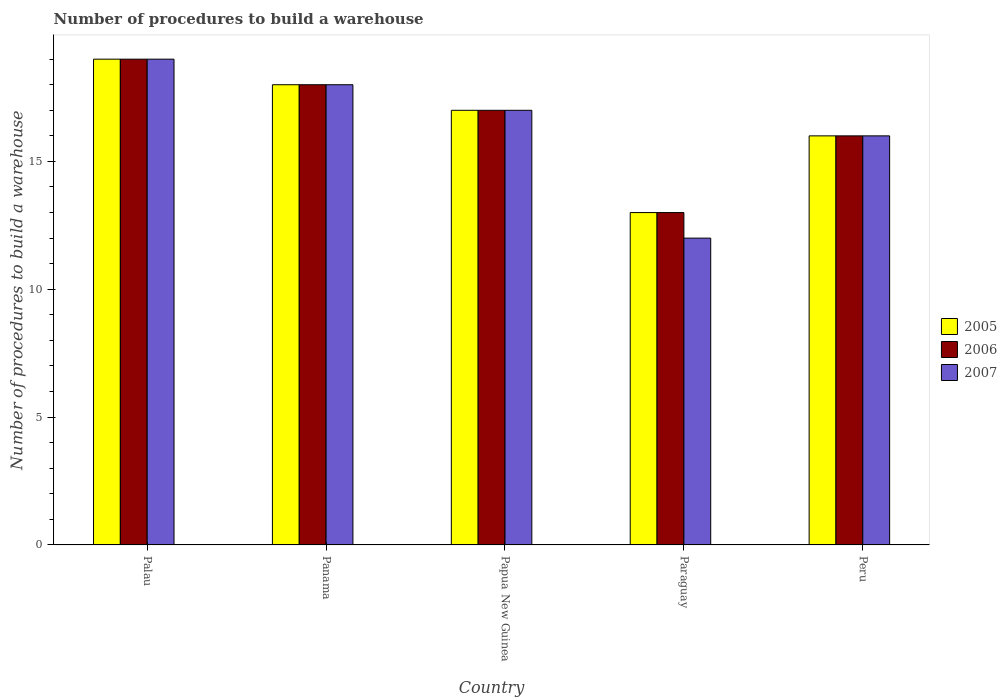How many different coloured bars are there?
Provide a short and direct response. 3. How many bars are there on the 2nd tick from the left?
Offer a very short reply. 3. What is the label of the 1st group of bars from the left?
Provide a succinct answer. Palau. What is the number of procedures to build a warehouse in in 2005 in Peru?
Your response must be concise. 16. Across all countries, what is the maximum number of procedures to build a warehouse in in 2007?
Keep it short and to the point. 19. In which country was the number of procedures to build a warehouse in in 2006 maximum?
Make the answer very short. Palau. In which country was the number of procedures to build a warehouse in in 2005 minimum?
Your answer should be very brief. Paraguay. What is the total number of procedures to build a warehouse in in 2007 in the graph?
Provide a short and direct response. 82. What is the difference between the number of procedures to build a warehouse in in 2007 in Peru and the number of procedures to build a warehouse in in 2005 in Panama?
Offer a terse response. -2. What is the difference between the number of procedures to build a warehouse in of/in 2007 and number of procedures to build a warehouse in of/in 2005 in Papua New Guinea?
Ensure brevity in your answer.  0. Is the number of procedures to build a warehouse in in 2005 in Palau less than that in Paraguay?
Offer a very short reply. No. Is it the case that in every country, the sum of the number of procedures to build a warehouse in in 2005 and number of procedures to build a warehouse in in 2007 is greater than the number of procedures to build a warehouse in in 2006?
Keep it short and to the point. Yes. How many bars are there?
Give a very brief answer. 15. Are all the bars in the graph horizontal?
Make the answer very short. No. How many countries are there in the graph?
Keep it short and to the point. 5. Does the graph contain any zero values?
Your answer should be very brief. No. Does the graph contain grids?
Provide a short and direct response. No. Where does the legend appear in the graph?
Ensure brevity in your answer.  Center right. How are the legend labels stacked?
Your answer should be compact. Vertical. What is the title of the graph?
Your response must be concise. Number of procedures to build a warehouse. What is the label or title of the X-axis?
Your answer should be compact. Country. What is the label or title of the Y-axis?
Make the answer very short. Number of procedures to build a warehouse. What is the Number of procedures to build a warehouse of 2005 in Palau?
Offer a very short reply. 19. What is the Number of procedures to build a warehouse of 2005 in Paraguay?
Provide a short and direct response. 13. What is the Number of procedures to build a warehouse in 2006 in Paraguay?
Your answer should be compact. 13. What is the Number of procedures to build a warehouse of 2007 in Paraguay?
Offer a very short reply. 12. What is the Number of procedures to build a warehouse of 2005 in Peru?
Offer a very short reply. 16. What is the Number of procedures to build a warehouse in 2007 in Peru?
Provide a succinct answer. 16. Across all countries, what is the maximum Number of procedures to build a warehouse of 2005?
Provide a short and direct response. 19. Across all countries, what is the minimum Number of procedures to build a warehouse in 2005?
Provide a short and direct response. 13. What is the total Number of procedures to build a warehouse in 2005 in the graph?
Your answer should be compact. 83. What is the total Number of procedures to build a warehouse in 2006 in the graph?
Offer a very short reply. 83. What is the total Number of procedures to build a warehouse in 2007 in the graph?
Provide a short and direct response. 82. What is the difference between the Number of procedures to build a warehouse of 2006 in Palau and that in Panama?
Your answer should be very brief. 1. What is the difference between the Number of procedures to build a warehouse of 2007 in Palau and that in Panama?
Offer a very short reply. 1. What is the difference between the Number of procedures to build a warehouse in 2005 in Palau and that in Papua New Guinea?
Provide a succinct answer. 2. What is the difference between the Number of procedures to build a warehouse in 2006 in Palau and that in Papua New Guinea?
Your answer should be compact. 2. What is the difference between the Number of procedures to build a warehouse of 2006 in Palau and that in Paraguay?
Your answer should be compact. 6. What is the difference between the Number of procedures to build a warehouse in 2007 in Palau and that in Paraguay?
Make the answer very short. 7. What is the difference between the Number of procedures to build a warehouse of 2006 in Palau and that in Peru?
Ensure brevity in your answer.  3. What is the difference between the Number of procedures to build a warehouse in 2006 in Panama and that in Papua New Guinea?
Offer a very short reply. 1. What is the difference between the Number of procedures to build a warehouse in 2005 in Panama and that in Paraguay?
Ensure brevity in your answer.  5. What is the difference between the Number of procedures to build a warehouse in 2007 in Panama and that in Paraguay?
Offer a terse response. 6. What is the difference between the Number of procedures to build a warehouse of 2005 in Panama and that in Peru?
Give a very brief answer. 2. What is the difference between the Number of procedures to build a warehouse in 2005 in Papua New Guinea and that in Paraguay?
Offer a terse response. 4. What is the difference between the Number of procedures to build a warehouse of 2006 in Papua New Guinea and that in Paraguay?
Ensure brevity in your answer.  4. What is the difference between the Number of procedures to build a warehouse in 2005 in Papua New Guinea and that in Peru?
Your response must be concise. 1. What is the difference between the Number of procedures to build a warehouse in 2006 in Papua New Guinea and that in Peru?
Your response must be concise. 1. What is the difference between the Number of procedures to build a warehouse of 2007 in Papua New Guinea and that in Peru?
Give a very brief answer. 1. What is the difference between the Number of procedures to build a warehouse in 2006 in Palau and the Number of procedures to build a warehouse in 2007 in Panama?
Provide a succinct answer. 1. What is the difference between the Number of procedures to build a warehouse in 2005 in Palau and the Number of procedures to build a warehouse in 2006 in Papua New Guinea?
Your answer should be very brief. 2. What is the difference between the Number of procedures to build a warehouse in 2006 in Palau and the Number of procedures to build a warehouse in 2007 in Papua New Guinea?
Offer a terse response. 2. What is the difference between the Number of procedures to build a warehouse of 2005 in Palau and the Number of procedures to build a warehouse of 2006 in Paraguay?
Your response must be concise. 6. What is the difference between the Number of procedures to build a warehouse in 2005 in Palau and the Number of procedures to build a warehouse in 2007 in Paraguay?
Ensure brevity in your answer.  7. What is the difference between the Number of procedures to build a warehouse of 2006 in Palau and the Number of procedures to build a warehouse of 2007 in Paraguay?
Give a very brief answer. 7. What is the difference between the Number of procedures to build a warehouse in 2005 in Palau and the Number of procedures to build a warehouse in 2006 in Peru?
Provide a short and direct response. 3. What is the difference between the Number of procedures to build a warehouse of 2005 in Palau and the Number of procedures to build a warehouse of 2007 in Peru?
Your answer should be compact. 3. What is the difference between the Number of procedures to build a warehouse in 2006 in Palau and the Number of procedures to build a warehouse in 2007 in Peru?
Provide a short and direct response. 3. What is the difference between the Number of procedures to build a warehouse of 2005 in Panama and the Number of procedures to build a warehouse of 2006 in Papua New Guinea?
Offer a very short reply. 1. What is the difference between the Number of procedures to build a warehouse of 2005 in Panama and the Number of procedures to build a warehouse of 2007 in Papua New Guinea?
Give a very brief answer. 1. What is the difference between the Number of procedures to build a warehouse in 2005 in Panama and the Number of procedures to build a warehouse in 2006 in Paraguay?
Ensure brevity in your answer.  5. What is the difference between the Number of procedures to build a warehouse in 2005 in Papua New Guinea and the Number of procedures to build a warehouse in 2006 in Paraguay?
Offer a terse response. 4. What is the difference between the Number of procedures to build a warehouse in 2006 in Papua New Guinea and the Number of procedures to build a warehouse in 2007 in Paraguay?
Make the answer very short. 5. What is the difference between the Number of procedures to build a warehouse of 2005 in Papua New Guinea and the Number of procedures to build a warehouse of 2007 in Peru?
Make the answer very short. 1. What is the difference between the Number of procedures to build a warehouse of 2006 in Papua New Guinea and the Number of procedures to build a warehouse of 2007 in Peru?
Your answer should be compact. 1. What is the difference between the Number of procedures to build a warehouse of 2005 in Paraguay and the Number of procedures to build a warehouse of 2006 in Peru?
Offer a terse response. -3. What is the difference between the Number of procedures to build a warehouse of 2006 in Paraguay and the Number of procedures to build a warehouse of 2007 in Peru?
Give a very brief answer. -3. What is the average Number of procedures to build a warehouse in 2006 per country?
Offer a terse response. 16.6. What is the average Number of procedures to build a warehouse of 2007 per country?
Provide a succinct answer. 16.4. What is the difference between the Number of procedures to build a warehouse in 2005 and Number of procedures to build a warehouse in 2007 in Palau?
Provide a succinct answer. 0. What is the difference between the Number of procedures to build a warehouse in 2006 and Number of procedures to build a warehouse in 2007 in Palau?
Your answer should be compact. 0. What is the difference between the Number of procedures to build a warehouse of 2005 and Number of procedures to build a warehouse of 2006 in Panama?
Offer a terse response. 0. What is the difference between the Number of procedures to build a warehouse in 2005 and Number of procedures to build a warehouse in 2007 in Panama?
Give a very brief answer. 0. What is the difference between the Number of procedures to build a warehouse of 2006 and Number of procedures to build a warehouse of 2007 in Panama?
Provide a short and direct response. 0. What is the difference between the Number of procedures to build a warehouse of 2005 and Number of procedures to build a warehouse of 2006 in Papua New Guinea?
Provide a short and direct response. 0. What is the difference between the Number of procedures to build a warehouse in 2006 and Number of procedures to build a warehouse in 2007 in Papua New Guinea?
Your response must be concise. 0. What is the difference between the Number of procedures to build a warehouse of 2005 and Number of procedures to build a warehouse of 2007 in Paraguay?
Your answer should be compact. 1. What is the difference between the Number of procedures to build a warehouse in 2006 and Number of procedures to build a warehouse in 2007 in Paraguay?
Keep it short and to the point. 1. What is the ratio of the Number of procedures to build a warehouse of 2005 in Palau to that in Panama?
Keep it short and to the point. 1.06. What is the ratio of the Number of procedures to build a warehouse in 2006 in Palau to that in Panama?
Your response must be concise. 1.06. What is the ratio of the Number of procedures to build a warehouse in 2007 in Palau to that in Panama?
Give a very brief answer. 1.06. What is the ratio of the Number of procedures to build a warehouse in 2005 in Palau to that in Papua New Guinea?
Provide a succinct answer. 1.12. What is the ratio of the Number of procedures to build a warehouse of 2006 in Palau to that in Papua New Guinea?
Your answer should be compact. 1.12. What is the ratio of the Number of procedures to build a warehouse of 2007 in Palau to that in Papua New Guinea?
Your answer should be very brief. 1.12. What is the ratio of the Number of procedures to build a warehouse of 2005 in Palau to that in Paraguay?
Offer a very short reply. 1.46. What is the ratio of the Number of procedures to build a warehouse of 2006 in Palau to that in Paraguay?
Give a very brief answer. 1.46. What is the ratio of the Number of procedures to build a warehouse in 2007 in Palau to that in Paraguay?
Provide a succinct answer. 1.58. What is the ratio of the Number of procedures to build a warehouse in 2005 in Palau to that in Peru?
Offer a very short reply. 1.19. What is the ratio of the Number of procedures to build a warehouse in 2006 in Palau to that in Peru?
Give a very brief answer. 1.19. What is the ratio of the Number of procedures to build a warehouse of 2007 in Palau to that in Peru?
Your answer should be very brief. 1.19. What is the ratio of the Number of procedures to build a warehouse of 2005 in Panama to that in Papua New Guinea?
Keep it short and to the point. 1.06. What is the ratio of the Number of procedures to build a warehouse in 2006 in Panama to that in Papua New Guinea?
Provide a succinct answer. 1.06. What is the ratio of the Number of procedures to build a warehouse of 2007 in Panama to that in Papua New Guinea?
Your answer should be compact. 1.06. What is the ratio of the Number of procedures to build a warehouse in 2005 in Panama to that in Paraguay?
Ensure brevity in your answer.  1.38. What is the ratio of the Number of procedures to build a warehouse in 2006 in Panama to that in Paraguay?
Ensure brevity in your answer.  1.38. What is the ratio of the Number of procedures to build a warehouse of 2007 in Panama to that in Paraguay?
Provide a short and direct response. 1.5. What is the ratio of the Number of procedures to build a warehouse in 2005 in Panama to that in Peru?
Make the answer very short. 1.12. What is the ratio of the Number of procedures to build a warehouse of 2006 in Panama to that in Peru?
Make the answer very short. 1.12. What is the ratio of the Number of procedures to build a warehouse in 2007 in Panama to that in Peru?
Your answer should be compact. 1.12. What is the ratio of the Number of procedures to build a warehouse in 2005 in Papua New Guinea to that in Paraguay?
Ensure brevity in your answer.  1.31. What is the ratio of the Number of procedures to build a warehouse of 2006 in Papua New Guinea to that in Paraguay?
Your response must be concise. 1.31. What is the ratio of the Number of procedures to build a warehouse of 2007 in Papua New Guinea to that in Paraguay?
Your answer should be very brief. 1.42. What is the ratio of the Number of procedures to build a warehouse of 2005 in Papua New Guinea to that in Peru?
Offer a very short reply. 1.06. What is the ratio of the Number of procedures to build a warehouse of 2007 in Papua New Guinea to that in Peru?
Offer a terse response. 1.06. What is the ratio of the Number of procedures to build a warehouse of 2005 in Paraguay to that in Peru?
Provide a succinct answer. 0.81. What is the ratio of the Number of procedures to build a warehouse of 2006 in Paraguay to that in Peru?
Your answer should be very brief. 0.81. What is the difference between the highest and the second highest Number of procedures to build a warehouse in 2005?
Provide a succinct answer. 1. What is the difference between the highest and the lowest Number of procedures to build a warehouse of 2005?
Provide a succinct answer. 6. What is the difference between the highest and the lowest Number of procedures to build a warehouse in 2006?
Ensure brevity in your answer.  6. 